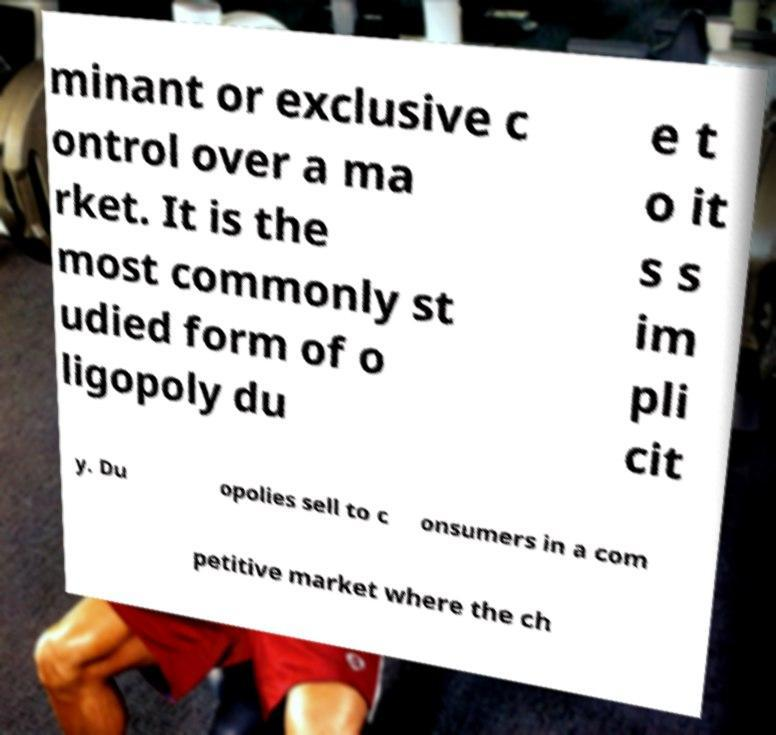Can you read and provide the text displayed in the image?This photo seems to have some interesting text. Can you extract and type it out for me? minant or exclusive c ontrol over a ma rket. It is the most commonly st udied form of o ligopoly du e t o it s s im pli cit y. Du opolies sell to c onsumers in a com petitive market where the ch 